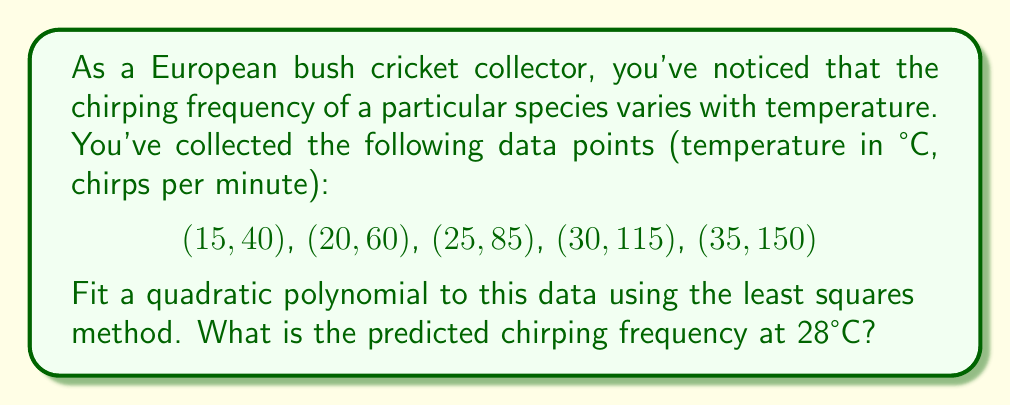Give your solution to this math problem. Let's approach this step-by-step:

1) We're fitting a quadratic polynomial of the form $y = ax^2 + bx + c$ to our data.

2) For the least squares method, we need to solve the normal equations:
   $$\begin{cases}
   \sum y = an\sum x^2 + b\sum x + cn \\
   \sum xy = a\sum x^3 + b\sum x^2 + c\sum x \\
   \sum x^2y = a\sum x^4 + b\sum x^3 + c\sum x^2
   \end{cases}$$

3) Let's calculate the required sums:
   $\sum x = 125$, $\sum y = 450$, $\sum x^2 = 3,375$, $\sum x^3 = 96,875$
   $\sum x^4 = 2,890,625$, $\sum xy = 12,275$, $\sum x^2y = 348,125$

4) Substituting these into our normal equations:
   $$\begin{cases}
   450 = 3,375a + 125b + 5c \\
   12,275 = 96,875a + 3,375b + 125c \\
   348,125 = 2,890,625a + 96,875b + 3,375c
   \end{cases}$$

5) Solving this system (you can use a calculator or computer algebra system), we get:
   $a \approx 0.1714$, $b \approx -1.2857$, $c \approx 27.1429$

6) Our fitted polynomial is:
   $y \approx 0.1714x^2 - 1.2857x + 27.1429$

7) To predict the chirping frequency at 28°C, we substitute $x = 28$:
   $y \approx 0.1714(28)^2 - 1.2857(28) + 27.1429 \approx 100.0002$

8) Rounding to the nearest whole number (as chirps are discrete), we get 100 chirps per minute.
Answer: 100 chirps per minute 